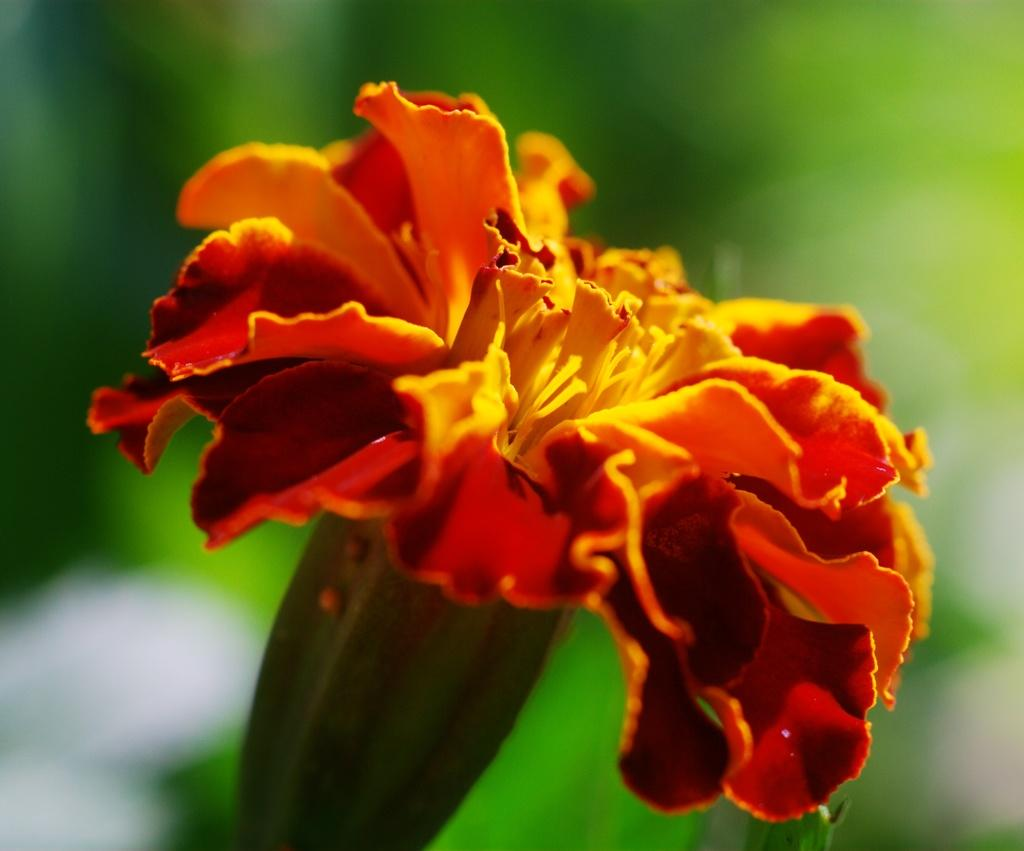What is the main subject of the image? There is a flower in the image. Can you describe the background of the image? The background of the image is blurred. What type of authority is depicted in the image? There is no authority figure present in the image; it features a flower and a blurred background. Can you describe the wave pattern visible in the image? There is no wave pattern present in the image; it features a flower and a blurred background. 